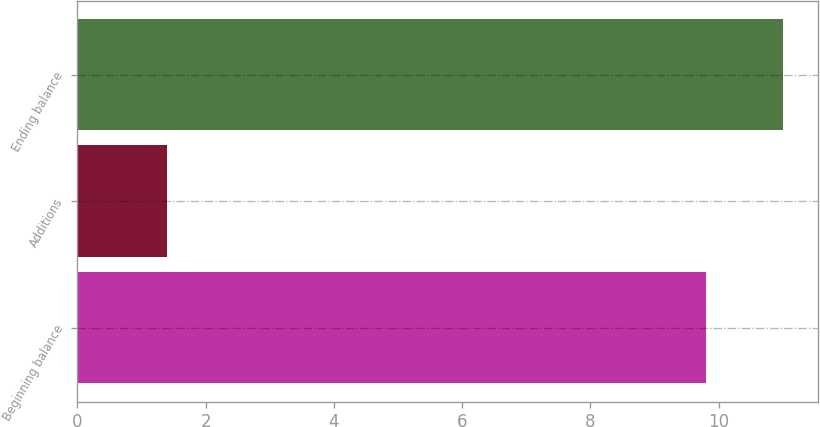Convert chart. <chart><loc_0><loc_0><loc_500><loc_500><bar_chart><fcel>Beginning balance<fcel>Additions<fcel>Ending balance<nl><fcel>9.8<fcel>1.4<fcel>11<nl></chart> 